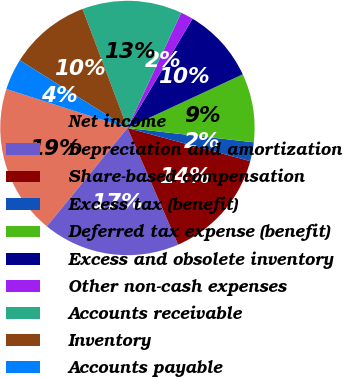Convert chart to OTSL. <chart><loc_0><loc_0><loc_500><loc_500><pie_chart><fcel>Net income<fcel>Depreciation and amortization<fcel>Share-based compensation<fcel>Excess tax (benefit)<fcel>Deferred tax expense (benefit)<fcel>Excess and obsolete inventory<fcel>Other non-cash expenses<fcel>Accounts receivable<fcel>Inventory<fcel>Accounts payable<nl><fcel>19.03%<fcel>17.45%<fcel>14.28%<fcel>2.4%<fcel>8.73%<fcel>9.52%<fcel>1.6%<fcel>12.69%<fcel>10.32%<fcel>3.98%<nl></chart> 